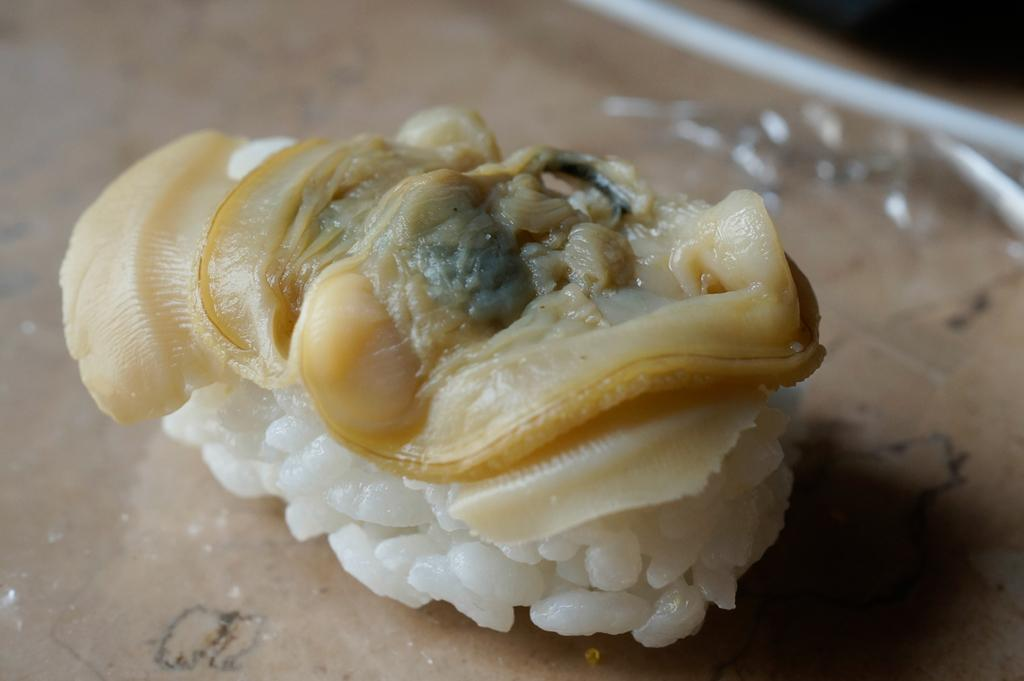What is present in the image? There is food stuff in the image. Where is the food stuff located? The food stuff is placed on a table. What type of fan is visible in the image? There is no fan present in the image. 